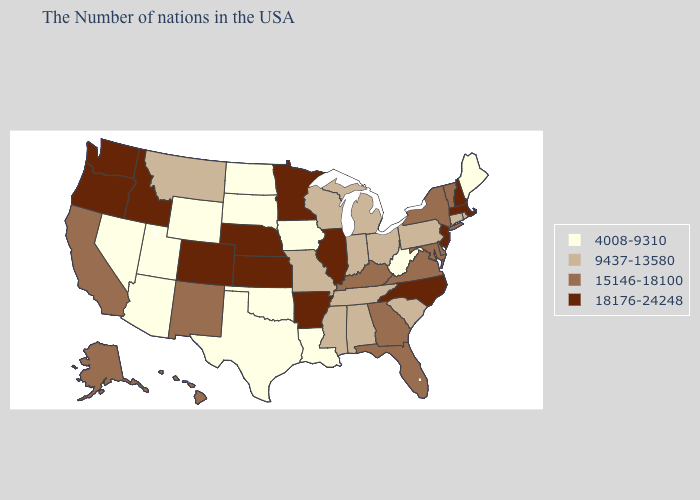Name the states that have a value in the range 4008-9310?
Give a very brief answer. Maine, West Virginia, Louisiana, Iowa, Oklahoma, Texas, South Dakota, North Dakota, Wyoming, Utah, Arizona, Nevada. Name the states that have a value in the range 9437-13580?
Give a very brief answer. Rhode Island, Connecticut, Pennsylvania, South Carolina, Ohio, Michigan, Indiana, Alabama, Tennessee, Wisconsin, Mississippi, Missouri, Montana. Name the states that have a value in the range 4008-9310?
Concise answer only. Maine, West Virginia, Louisiana, Iowa, Oklahoma, Texas, South Dakota, North Dakota, Wyoming, Utah, Arizona, Nevada. Does North Dakota have the lowest value in the USA?
Give a very brief answer. Yes. Name the states that have a value in the range 15146-18100?
Give a very brief answer. Vermont, New York, Delaware, Maryland, Virginia, Florida, Georgia, Kentucky, New Mexico, California, Alaska, Hawaii. Name the states that have a value in the range 18176-24248?
Answer briefly. Massachusetts, New Hampshire, New Jersey, North Carolina, Illinois, Arkansas, Minnesota, Kansas, Nebraska, Colorado, Idaho, Washington, Oregon. Does Massachusetts have the highest value in the Northeast?
Write a very short answer. Yes. Does Montana have the lowest value in the USA?
Quick response, please. No. Among the states that border Arkansas , which have the lowest value?
Keep it brief. Louisiana, Oklahoma, Texas. What is the value of South Dakota?
Write a very short answer. 4008-9310. Is the legend a continuous bar?
Be succinct. No. What is the value of North Dakota?
Short answer required. 4008-9310. Among the states that border Illinois , which have the lowest value?
Concise answer only. Iowa. What is the value of Massachusetts?
Keep it brief. 18176-24248. Which states hav the highest value in the Northeast?
Be succinct. Massachusetts, New Hampshire, New Jersey. 